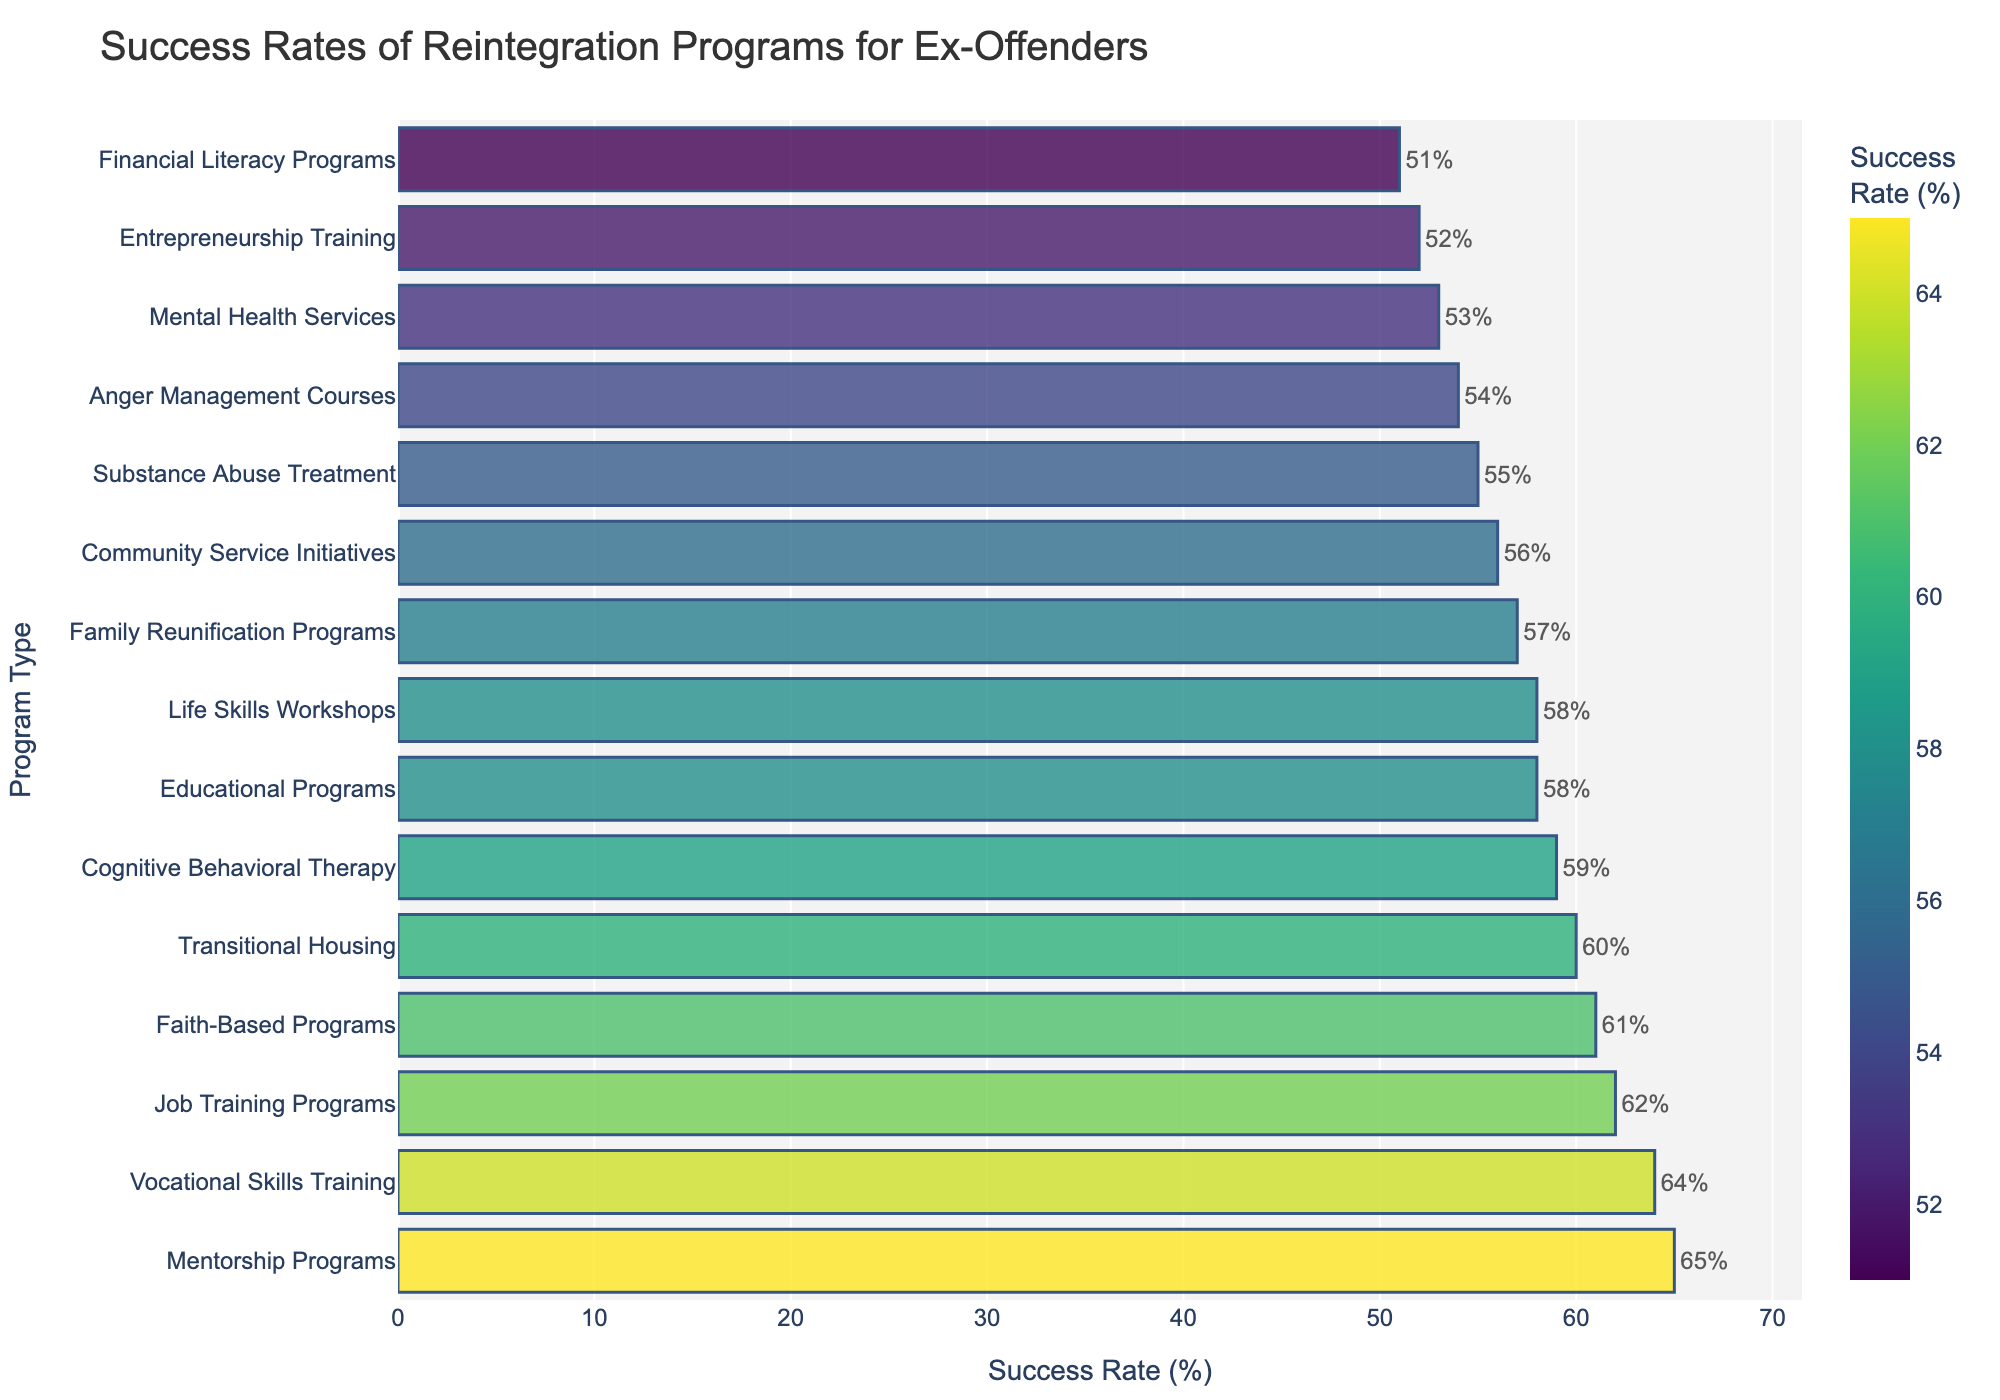which reintegration program has the highest success rate? Mentorship Programs have the highest success rate as seen from the tallest bar on the chart with a 65% success rate.
Answer: Mentorship Programs which program has a lower success rate, substance abuse treatment or educational programs? Substance Abuse Treatment has a lower success rate compared to Educational Programs. Substance Abuse Treatment is at 55%, while Educational Programs are at 58%.
Answer: Substance Abuse Treatment what's the difference in success rates between cognitive behavioral therapy and vocational skills training? Vocational Skills Training has a success rate of 64%, and Cognitive Behavioral Therapy has a success rate of 59%. The difference is 64 - 59 = 5%.
Answer: 5% how many programs have a success rate above 60%? By counting the bars with a success rate greater than 60%, there are 5 programs: Job Training Programs, Transitional Housing, Mentorship Programs, Vocational Skills Training, and Faith-Based Programs.
Answer: 5 which program type shows the highest success rate, and by how much is it higher than the program with the lowest success rate? Mentorship Programs show the highest success rate at 65%, while Financial Literacy Programs have the lowest success rate at 51%. The difference is 65 - 51 = 14%.
Answer: 14% is the success rate for life skills workshops greater than that for anger management courses? Yes, Life Skills Workshops have a success rate of 58%, which is greater than the 54% success rate for Anger Management Courses.
Answer: Yes what's the median success rate of all the programs? To find the median, we list all success rates: 51, 52, 53, 54, 55, 56, 57, 58, 58, 59, 60, 61, 62, 64, 65. The median value (the middle one) is 58%.
Answer: 58% which programs have a success rate within the range of 55% to 60%? The programs within the range of 55% to 60% are Substance Abuse Treatment (55%), Family Reunification Programs (57%), Cognitive Behavioral Therapy (59%), Community Service Initiatives (56%), and Life Skills Workshops (58%).
Answer: Substance Abuse Treatment, Family Reunification Programs, Cognitive Behavioral Therapy, Community Service Initiatives, Life Skills Workshops is the success rate for transitional housing the highest among all housing-related programs? Yes, Transitional Housing has a success rate of 60%, and there are no other housing-related programs listed with a higher success rate.
Answer: Yes From the top five programs with the highest success rates, which program ranks third? The top five programs are Mentorship Programs (65%), Vocational Skills Training (64%), Job Training Programs (62%), Faith-Based Programs (61%), and Transitional Housing (60%). Job Training Programs rank third.
Answer: Job Training Programs 